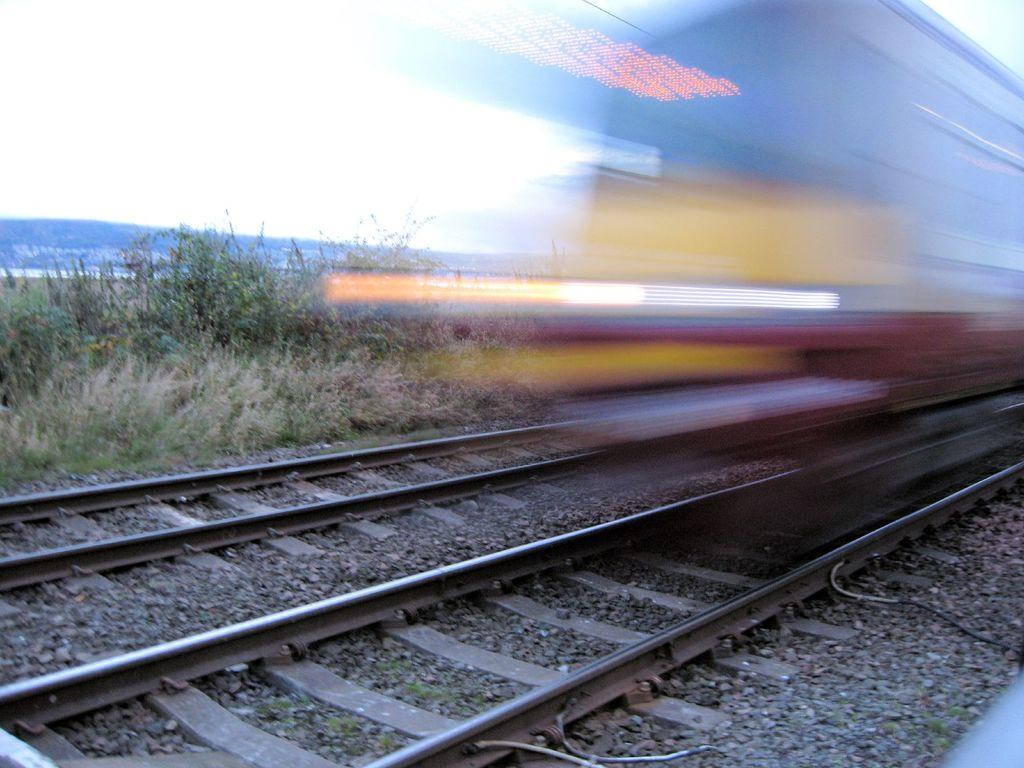What type of transportation infrastructure is present in the image? There are railway tracks in the image. What type of natural environment can be seen in the image? There is grass visible in the image. Can you describe the main subject of the image? There is a train in the image, although it appears blurry. What type of ornament is hanging from the train in the image? There is no ornament hanging from the train in the image; it appears blurry and the focus is on the railway tracks and grass. Is the image taken during winter, given the presence of snow? There is no snow visible in the image, so it cannot be determined if the image was taken during winter. 